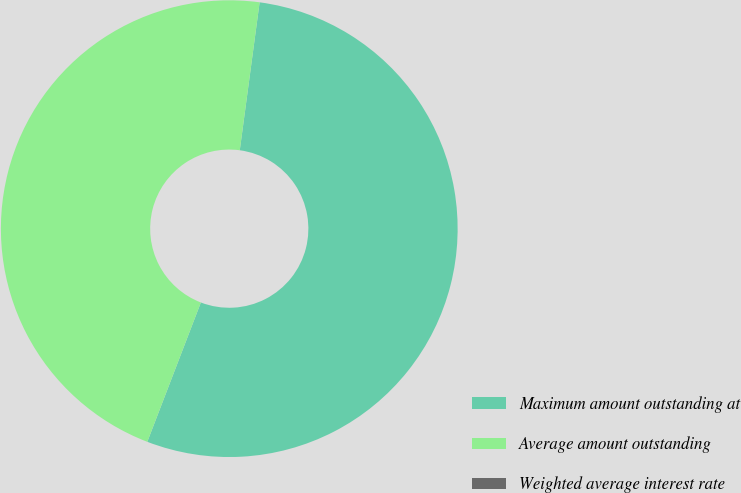<chart> <loc_0><loc_0><loc_500><loc_500><pie_chart><fcel>Maximum amount outstanding at<fcel>Average amount outstanding<fcel>Weighted average interest rate<nl><fcel>53.72%<fcel>46.28%<fcel>0.0%<nl></chart> 